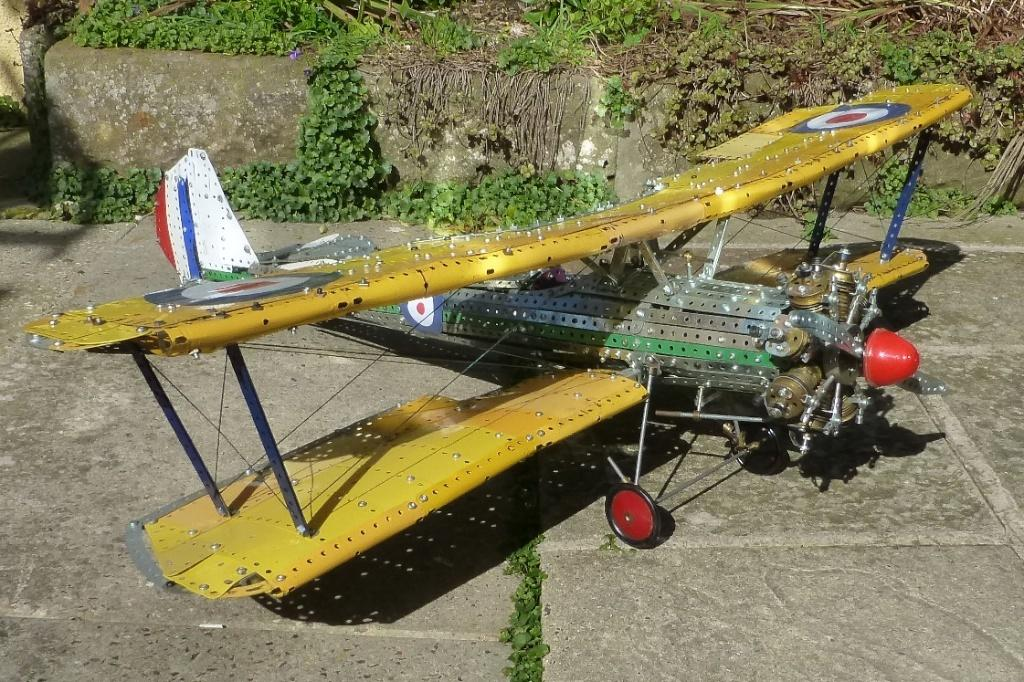What is the main subject of the image? The main subject of the image is an aeroplane made with iron things. Can you describe the materials used to create the aeroplane? The aeroplane is made with iron things. What can be seen in the background of the image? There are plants in the back side of the image. What type of magic is being performed with the iron aeroplane in the image? There is no magic being performed in the image; it simply shows an aeroplane made with iron things. What statement is being made by the presence of plants in the image? The presence of plants in the image does not make a specific statement; it simply provides context for the location or setting. 